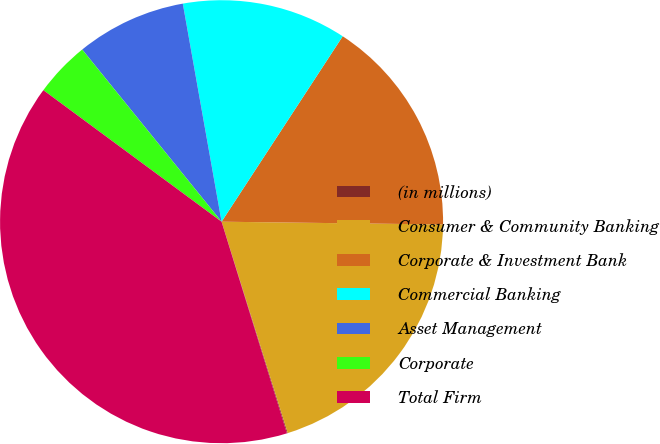<chart> <loc_0><loc_0><loc_500><loc_500><pie_chart><fcel>(in millions)<fcel>Consumer & Community Banking<fcel>Corporate & Investment Bank<fcel>Commercial Banking<fcel>Asset Management<fcel>Corporate<fcel>Total Firm<nl><fcel>0.06%<fcel>19.97%<fcel>15.99%<fcel>12.01%<fcel>8.03%<fcel>4.05%<fcel>39.89%<nl></chart> 